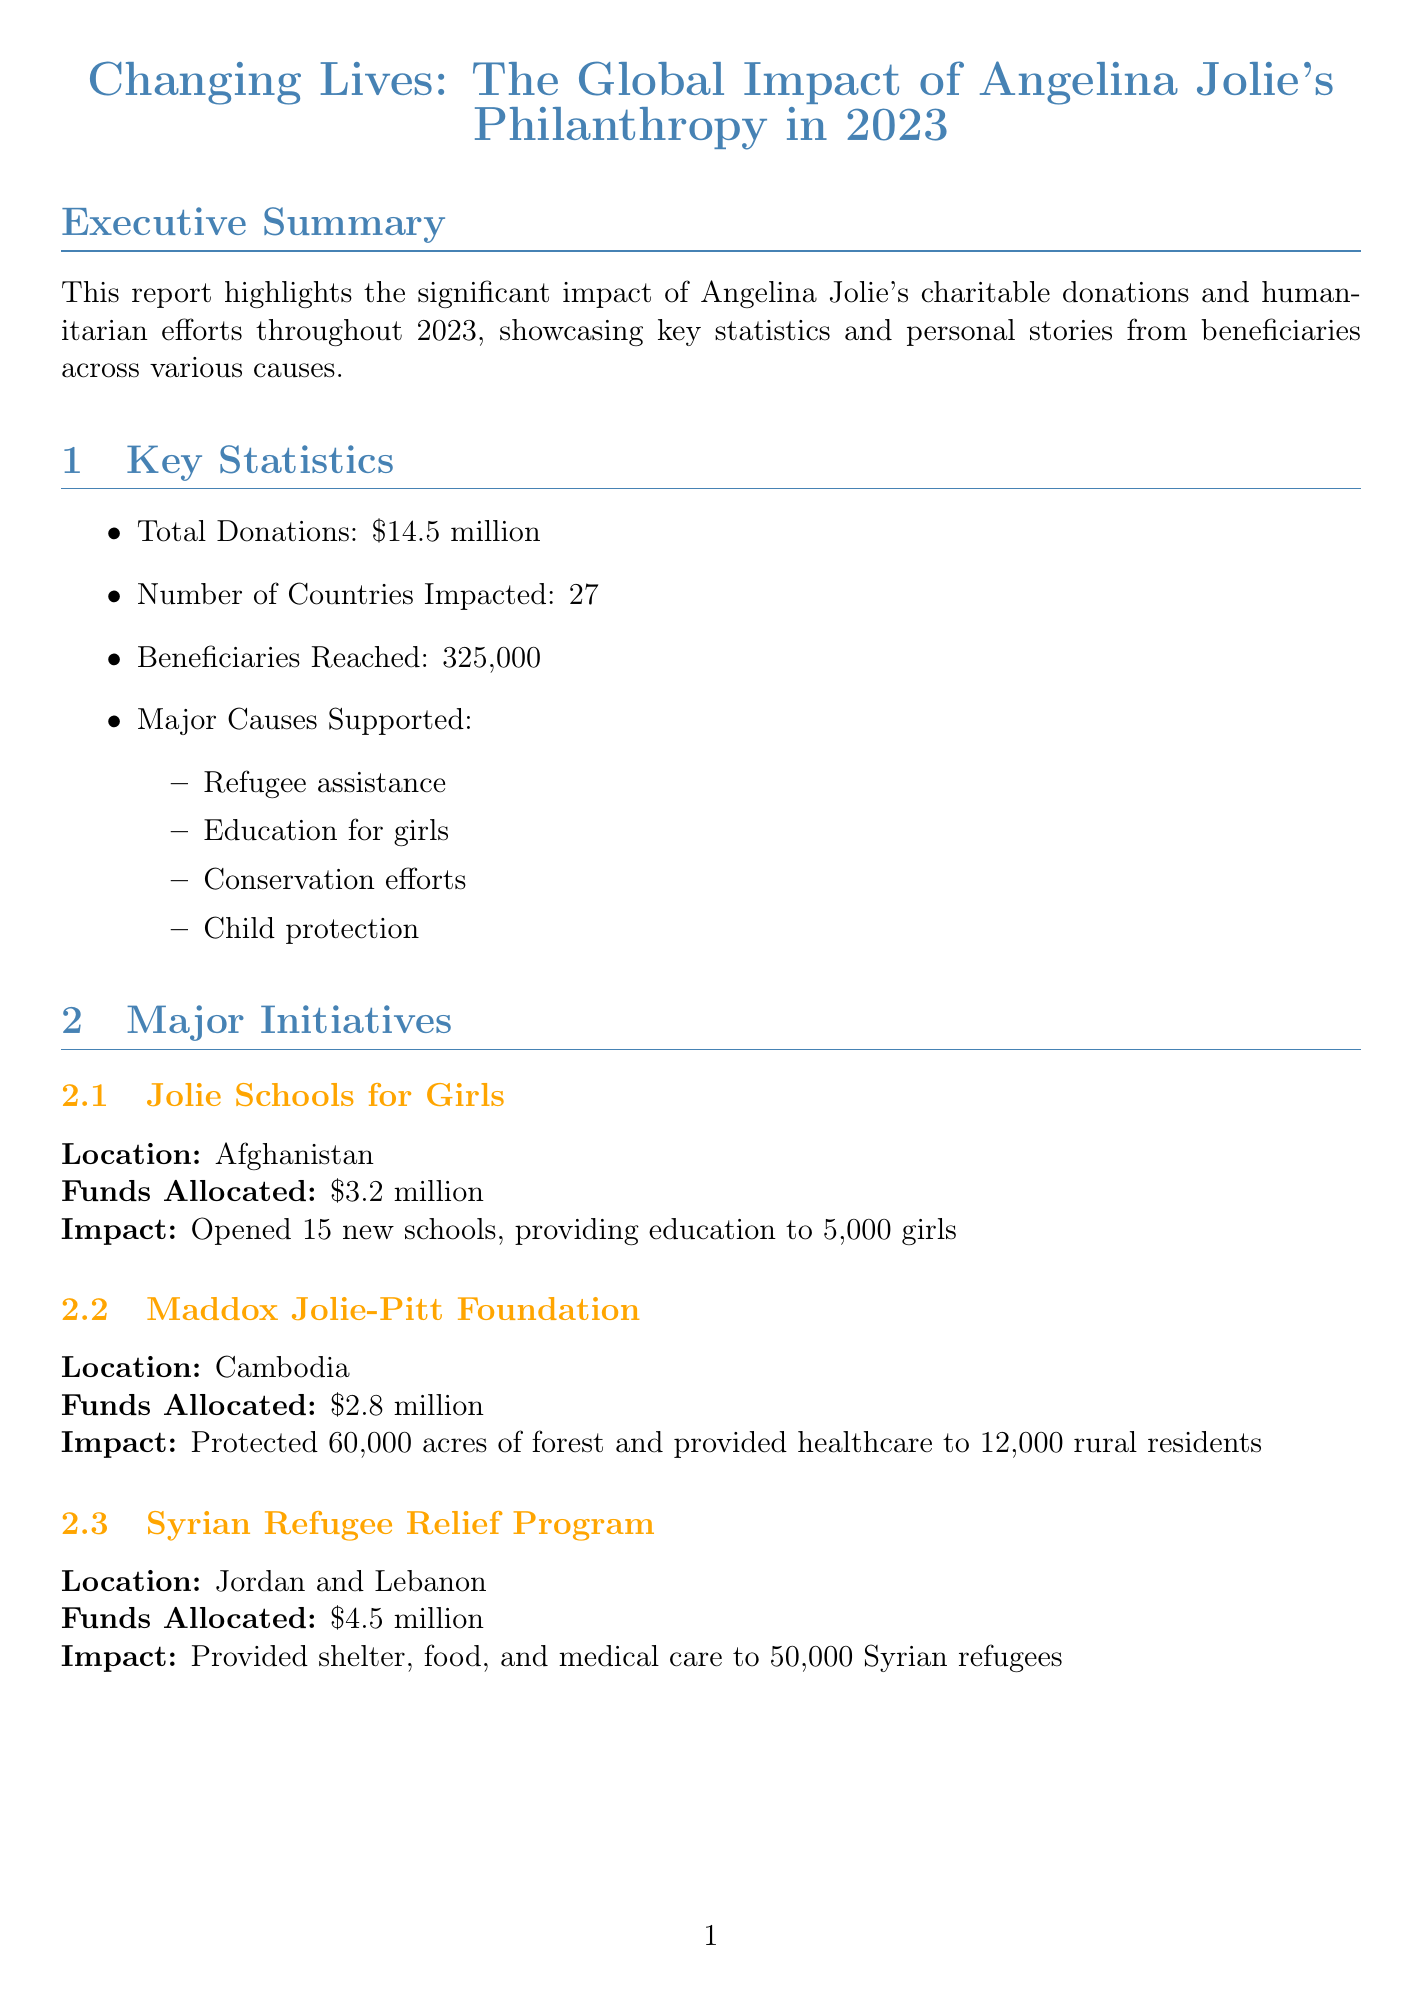what is the total amount of donations in 2023? The total amount of donations mentioned in the report is $14.5 million.
Answer: $14.5 million how many countries were impacted by the charitable donations? The report states that 27 countries were impacted by the charitable donations.
Answer: 27 what is the major cause supported with the highest funds allocated? The major cause with the highest funds allocated is the Syrian Refugee Relief Program, with $4.5 million.
Answer: $4.5 million who is the beneficiary from the Za'atari Refugee Camp? The beneficiary from the Za'atari Refugee Camp is Fatima Al-Hassan.
Answer: Fatima Al-Hassan which organization received $750,000 for a project? UNESCO received $750,000 for a project related to digital learning platforms for conflict-affected areas.
Answer: UNESCO what is one of the future goals mentioned in the report? One of the future goals is to expand the Jolie Schools for Girls program to 5 additional countries.
Answer: Expand the Jolie Schools for Girls program to 5 additional countries how many beneficiaries reached the initiatives outlined in the report? The report indicates that 325,000 beneficiaries were reached through the initiatives.
Answer: 325,000 what type of stories are showcased in the report? The report showcases personal stories from beneficiaries of the charitable initiatives.
Answer: Beneficiary stories what is the contribution amount for the reforestation project in the Amazon? The contribution amount for the reforestation project in the Amazon rainforest is $1 million.
Answer: $1 million 